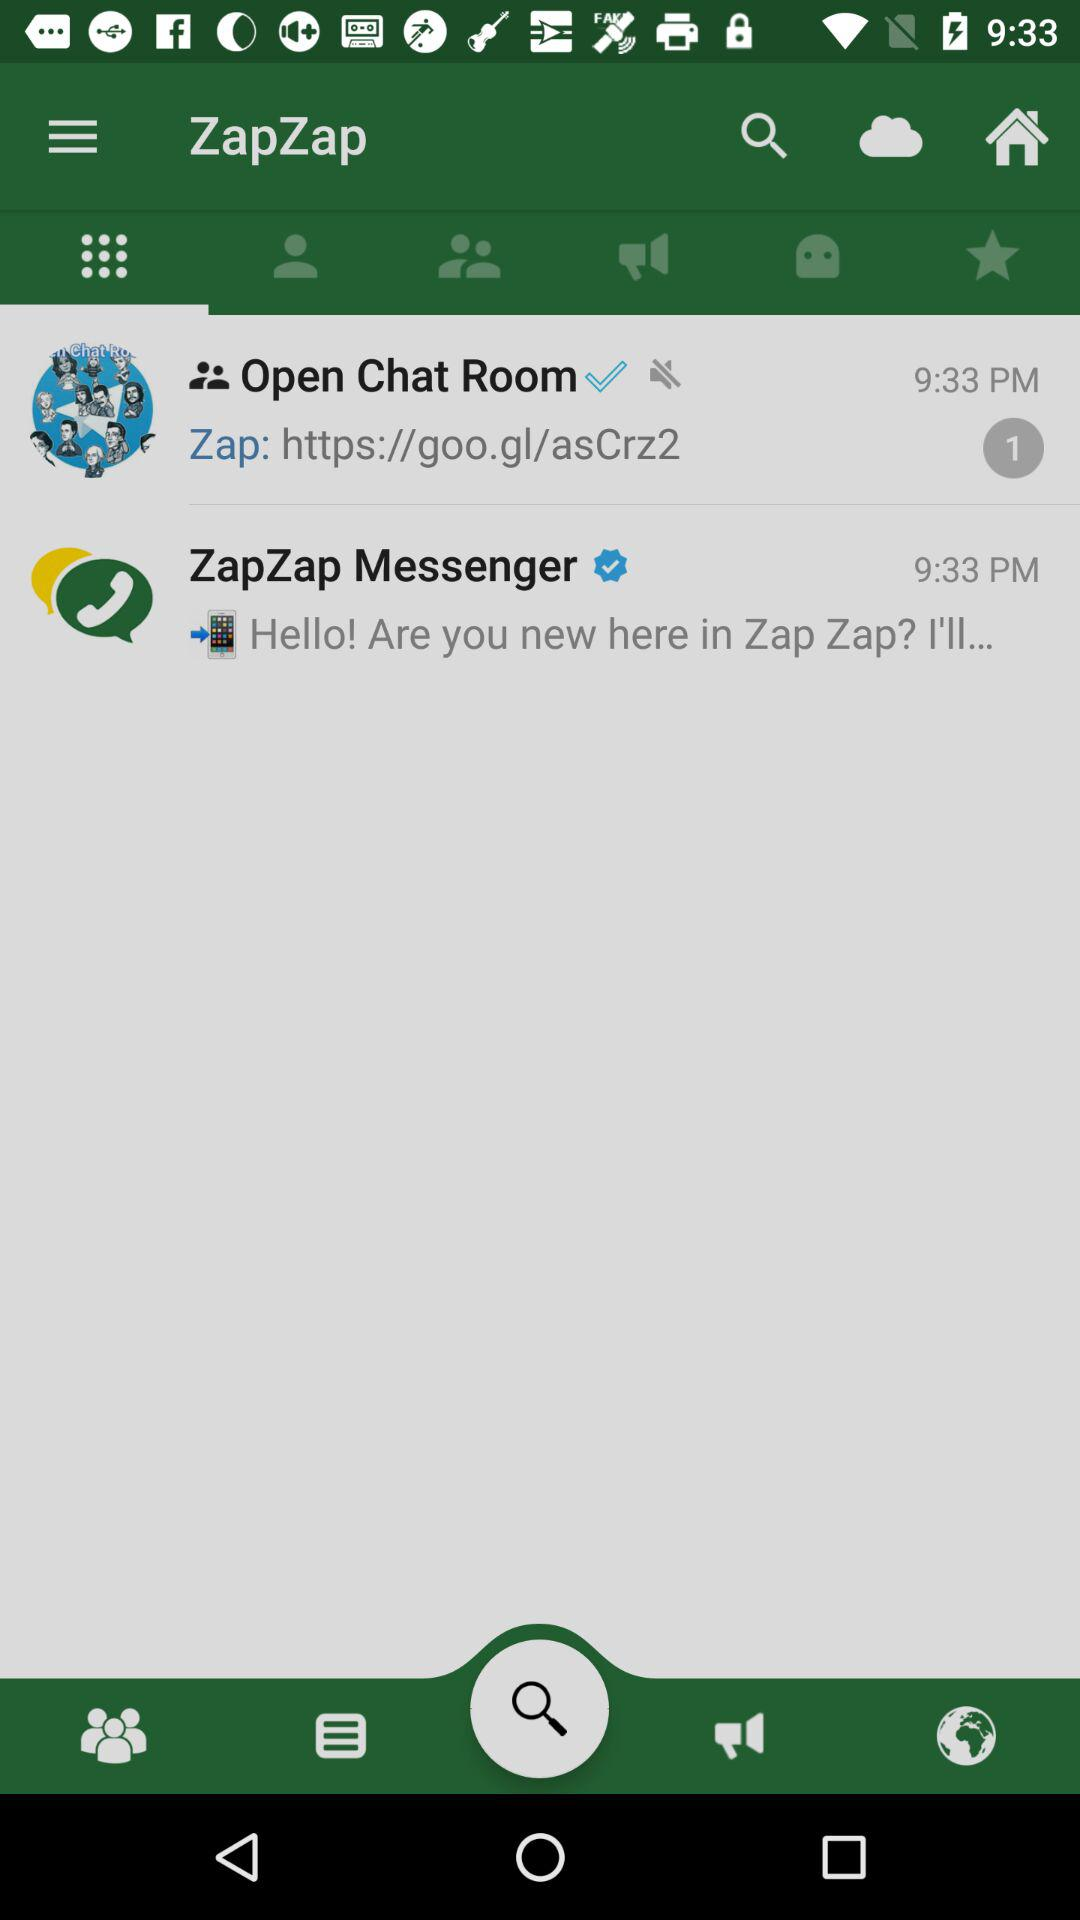What is the number of unread messages? The number of unread messages is 1. 